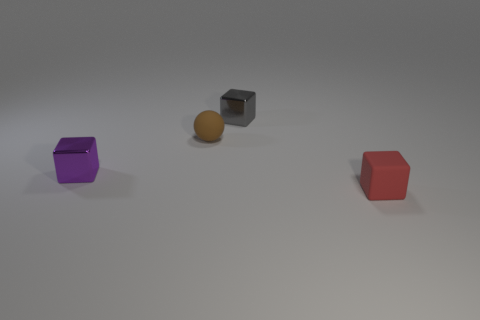Subtract all small matte blocks. How many blocks are left? 2 Add 3 green metallic things. How many objects exist? 7 Subtract all cubes. How many objects are left? 1 Subtract 1 blocks. How many blocks are left? 2 Subtract all purple metal objects. Subtract all purple metal blocks. How many objects are left? 2 Add 1 purple objects. How many purple objects are left? 2 Add 3 tiny brown objects. How many tiny brown objects exist? 4 Subtract 0 cyan blocks. How many objects are left? 4 Subtract all blue spheres. Subtract all red cylinders. How many spheres are left? 1 